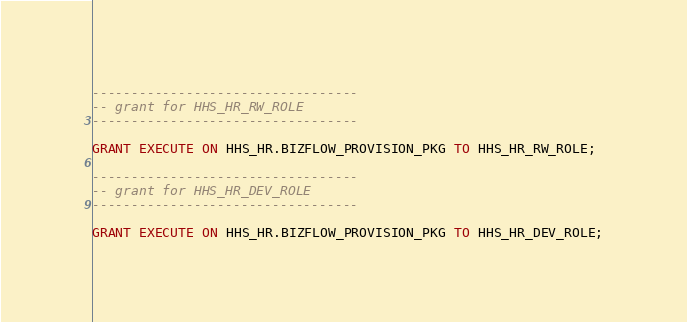<code> <loc_0><loc_0><loc_500><loc_500><_SQL_>
----------------------------------
-- grant for HHS_HR_RW_ROLE
----------------------------------

GRANT EXECUTE ON HHS_HR.BIZFLOW_PROVISION_PKG TO HHS_HR_RW_ROLE;

----------------------------------
-- grant for HHS_HR_DEV_ROLE
----------------------------------

GRANT EXECUTE ON HHS_HR.BIZFLOW_PROVISION_PKG TO HHS_HR_DEV_ROLE;

</code> 